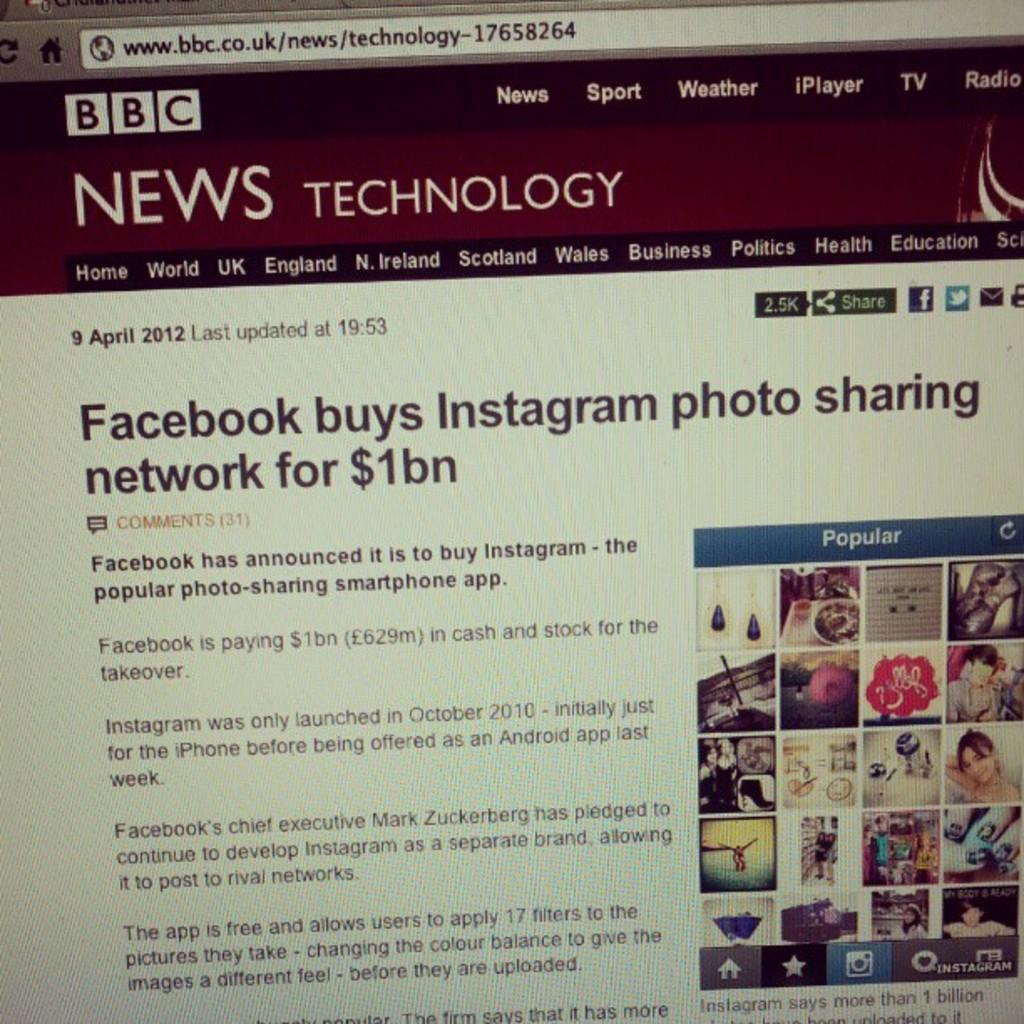<image>
Render a clear and concise summary of the photo. A web page from the BBC has an article about Facebook buying Instagram. 